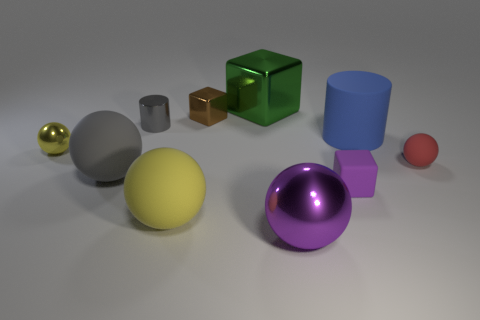Discuss the textures visible on the objects. The objects display a variety of textures: the golden sphere has a reflective glossy surface, the rubber ball appears matte with a slight rubbery texture, and the metal cylinder seems smooth with a metallic sheen. The transparent green cube has a clear, glass-like texture, which contrasts with the opaque and solid-colored objects. 